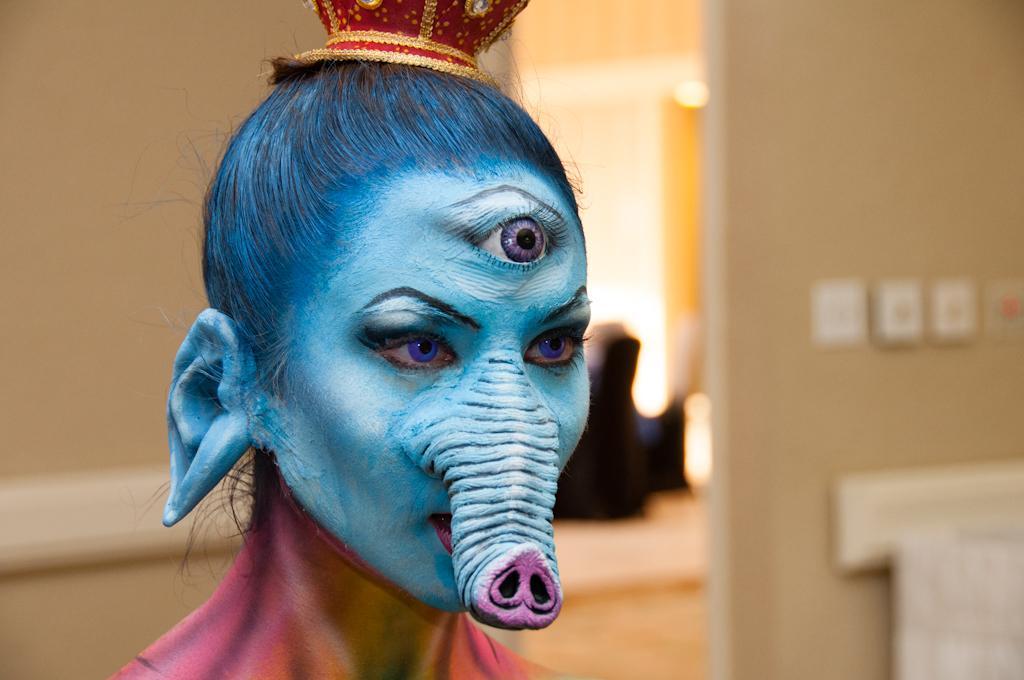Please provide a concise description of this image. In this image in the foreground there is a person. the person is wearing makeup. The person is having big ear, third eye and a trunk. The person is wearing a cap. In the background there is wall. The background is blurry. 